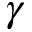<formula> <loc_0><loc_0><loc_500><loc_500>\gamma</formula> 